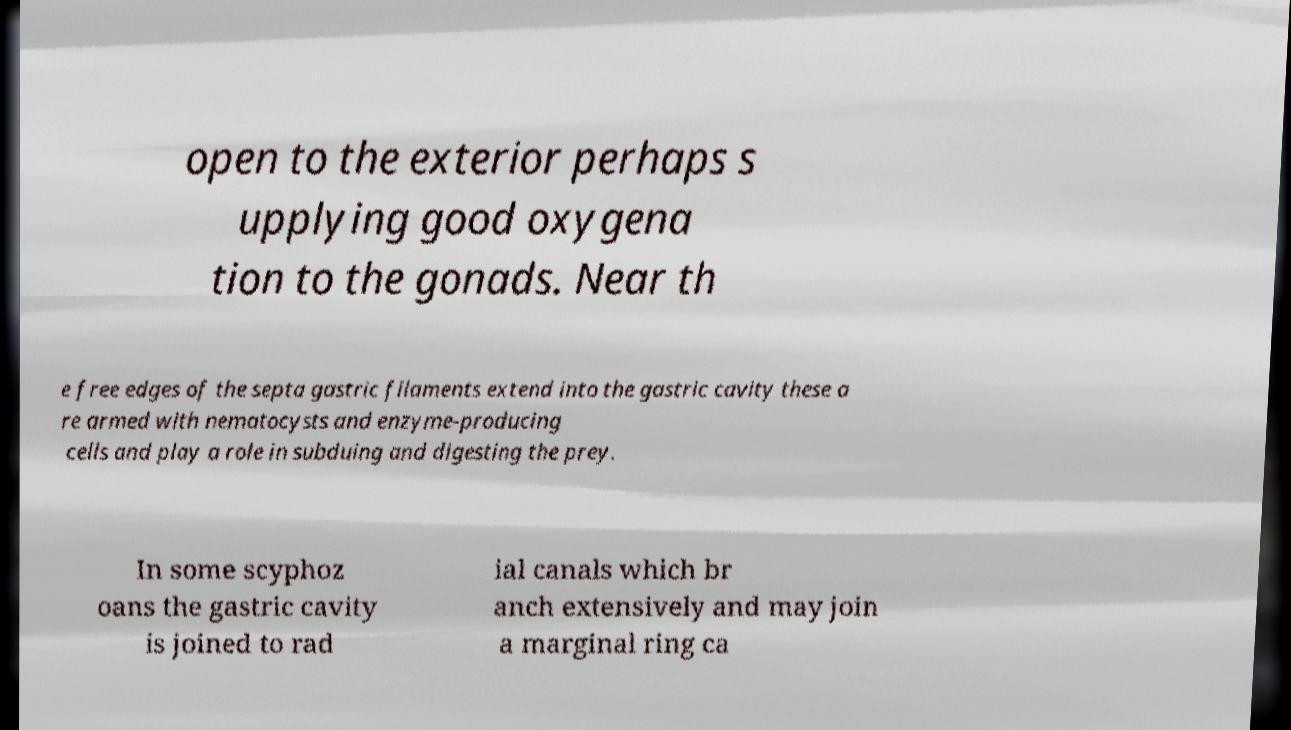I need the written content from this picture converted into text. Can you do that? open to the exterior perhaps s upplying good oxygena tion to the gonads. Near th e free edges of the septa gastric filaments extend into the gastric cavity these a re armed with nematocysts and enzyme-producing cells and play a role in subduing and digesting the prey. In some scyphoz oans the gastric cavity is joined to rad ial canals which br anch extensively and may join a marginal ring ca 